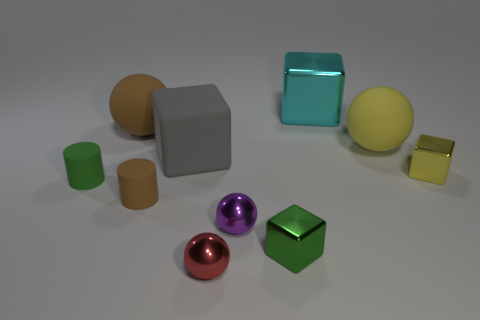The rubber cylinder in front of the small thing that is to the left of the matte ball left of the green metallic block is what color?
Your response must be concise. Brown. Does the big cyan object have the same material as the thing left of the large brown rubber ball?
Offer a very short reply. No. There is a red metal thing that is the same shape as the tiny purple thing; what is its size?
Your response must be concise. Small. Is the number of brown objects that are behind the tiny purple thing the same as the number of big yellow spheres that are behind the big yellow rubber ball?
Give a very brief answer. No. How many other objects are the same material as the big yellow sphere?
Offer a terse response. 4. Is the number of tiny brown rubber objects that are in front of the tiny green block the same as the number of cyan cylinders?
Offer a terse response. Yes. Do the green rubber thing and the brown matte thing that is in front of the green cylinder have the same size?
Your answer should be compact. Yes. What shape is the green object to the left of the rubber cube?
Offer a terse response. Cylinder. Is there anything else that is the same shape as the big brown rubber thing?
Your response must be concise. Yes. Are there any big spheres?
Your answer should be very brief. Yes. 